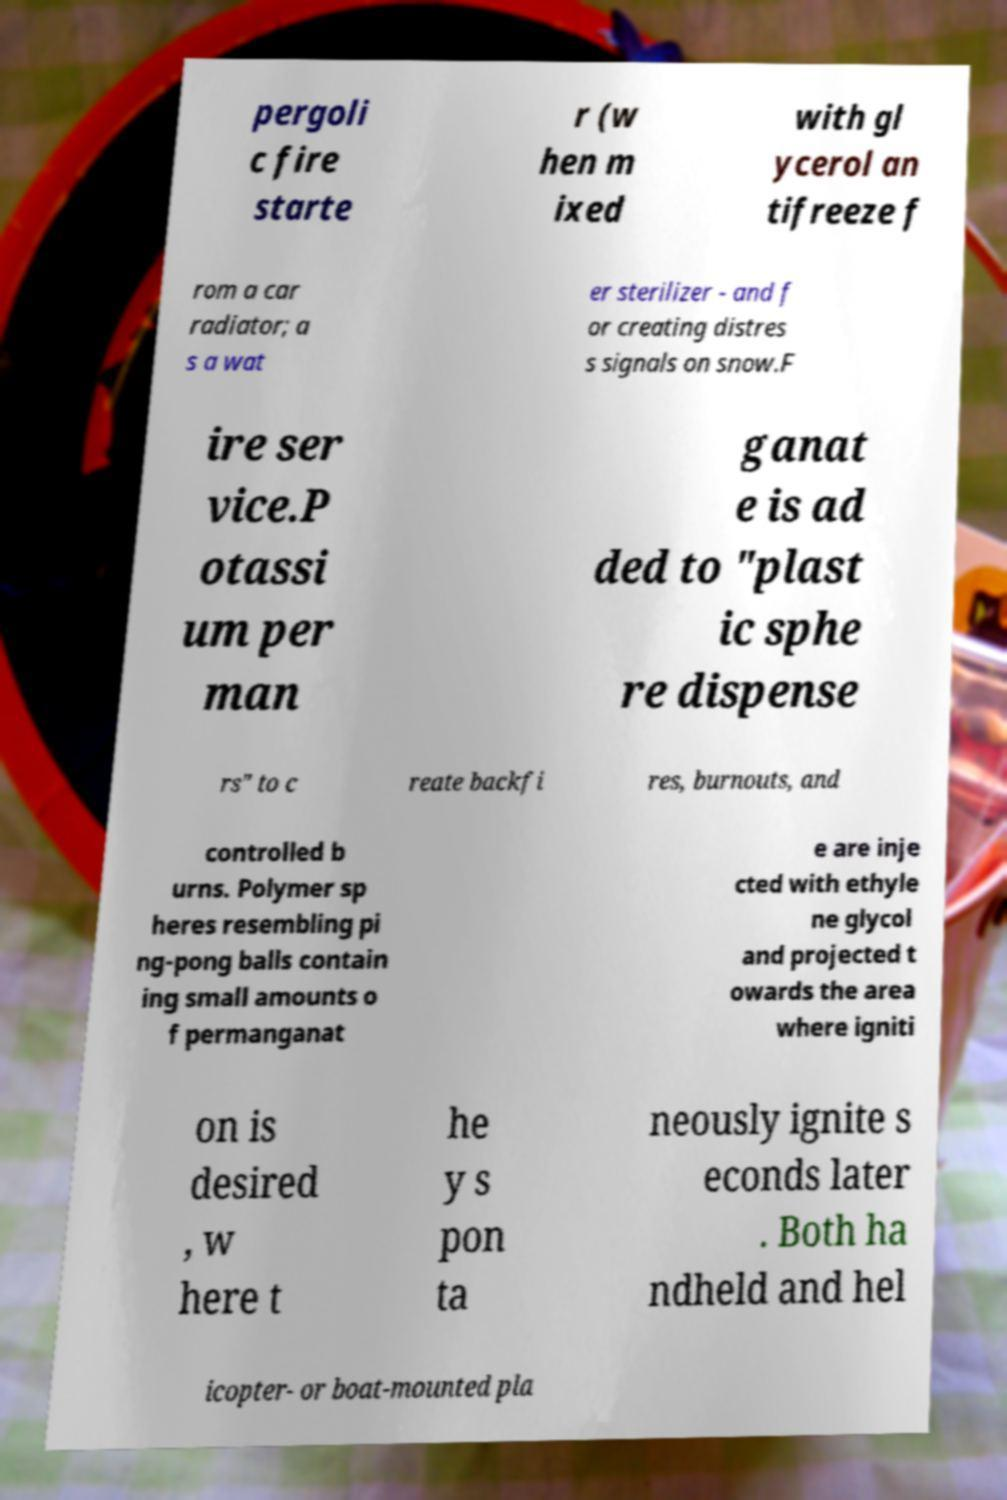What messages or text are displayed in this image? I need them in a readable, typed format. pergoli c fire starte r (w hen m ixed with gl ycerol an tifreeze f rom a car radiator; a s a wat er sterilizer - and f or creating distres s signals on snow.F ire ser vice.P otassi um per man ganat e is ad ded to "plast ic sphe re dispense rs" to c reate backfi res, burnouts, and controlled b urns. Polymer sp heres resembling pi ng-pong balls contain ing small amounts o f permanganat e are inje cted with ethyle ne glycol and projected t owards the area where igniti on is desired , w here t he y s pon ta neously ignite s econds later . Both ha ndheld and hel icopter- or boat-mounted pla 